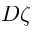<formula> <loc_0><loc_0><loc_500><loc_500>D \zeta</formula> 